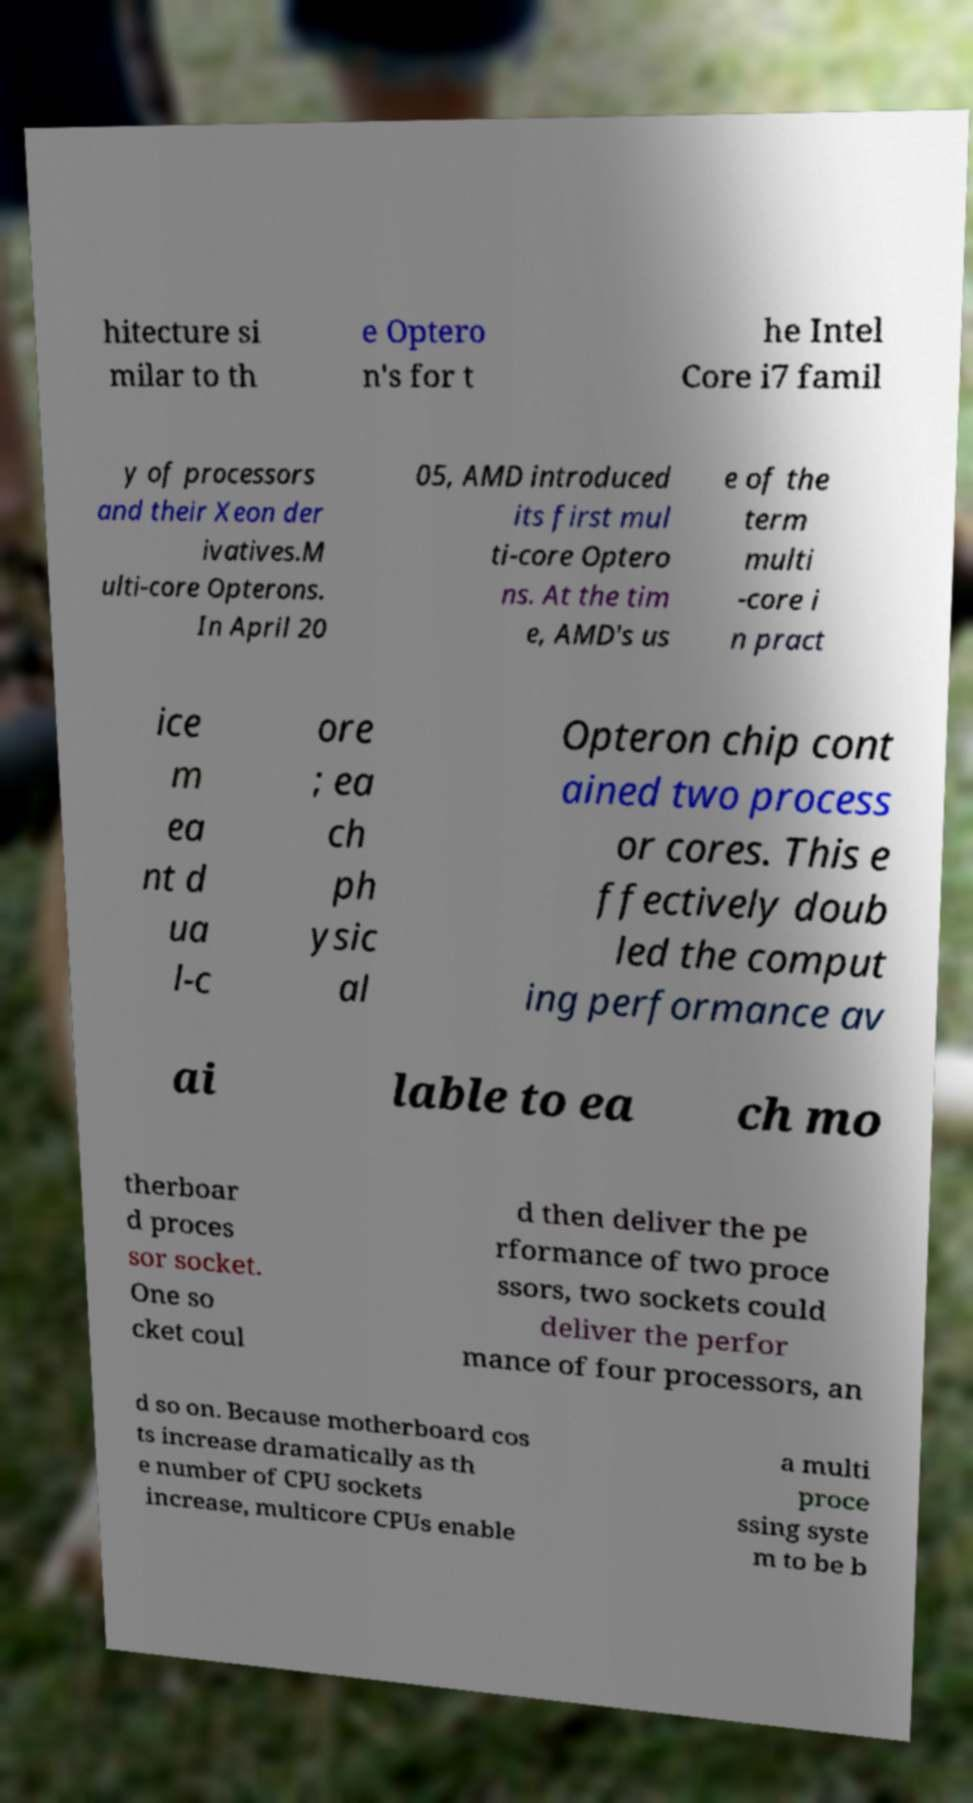Can you accurately transcribe the text from the provided image for me? hitecture si milar to th e Optero n's for t he Intel Core i7 famil y of processors and their Xeon der ivatives.M ulti-core Opterons. In April 20 05, AMD introduced its first mul ti-core Optero ns. At the tim e, AMD's us e of the term multi -core i n pract ice m ea nt d ua l-c ore ; ea ch ph ysic al Opteron chip cont ained two process or cores. This e ffectively doub led the comput ing performance av ai lable to ea ch mo therboar d proces sor socket. One so cket coul d then deliver the pe rformance of two proce ssors, two sockets could deliver the perfor mance of four processors, an d so on. Because motherboard cos ts increase dramatically as th e number of CPU sockets increase, multicore CPUs enable a multi proce ssing syste m to be b 